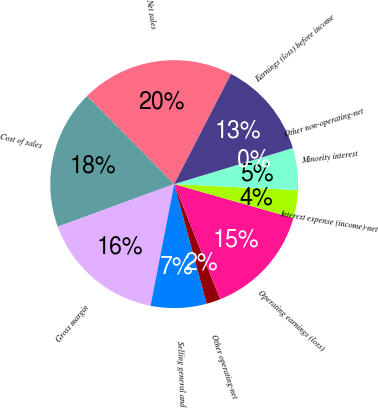Convert chart. <chart><loc_0><loc_0><loc_500><loc_500><pie_chart><fcel>Net sales<fcel>Cost of sales<fcel>Gross margin<fcel>Selling general and<fcel>Other operating-net<fcel>Operating earnings (loss)<fcel>Interest expense (income)-net<fcel>Minority interest<fcel>Other non-operating-net<fcel>Earnings (loss) before income<nl><fcel>19.99%<fcel>18.17%<fcel>16.36%<fcel>7.28%<fcel>1.83%<fcel>14.54%<fcel>3.64%<fcel>5.46%<fcel>0.01%<fcel>12.72%<nl></chart> 